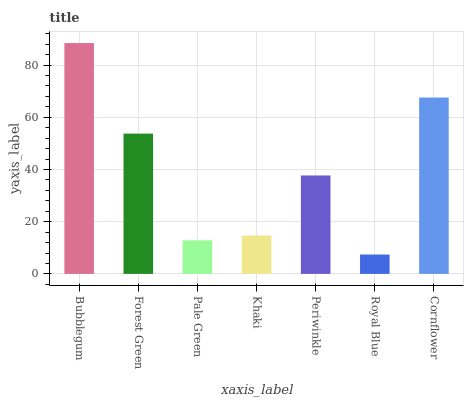Is Royal Blue the minimum?
Answer yes or no. Yes. Is Bubblegum the maximum?
Answer yes or no. Yes. Is Forest Green the minimum?
Answer yes or no. No. Is Forest Green the maximum?
Answer yes or no. No. Is Bubblegum greater than Forest Green?
Answer yes or no. Yes. Is Forest Green less than Bubblegum?
Answer yes or no. Yes. Is Forest Green greater than Bubblegum?
Answer yes or no. No. Is Bubblegum less than Forest Green?
Answer yes or no. No. Is Periwinkle the high median?
Answer yes or no. Yes. Is Periwinkle the low median?
Answer yes or no. Yes. Is Bubblegum the high median?
Answer yes or no. No. Is Bubblegum the low median?
Answer yes or no. No. 